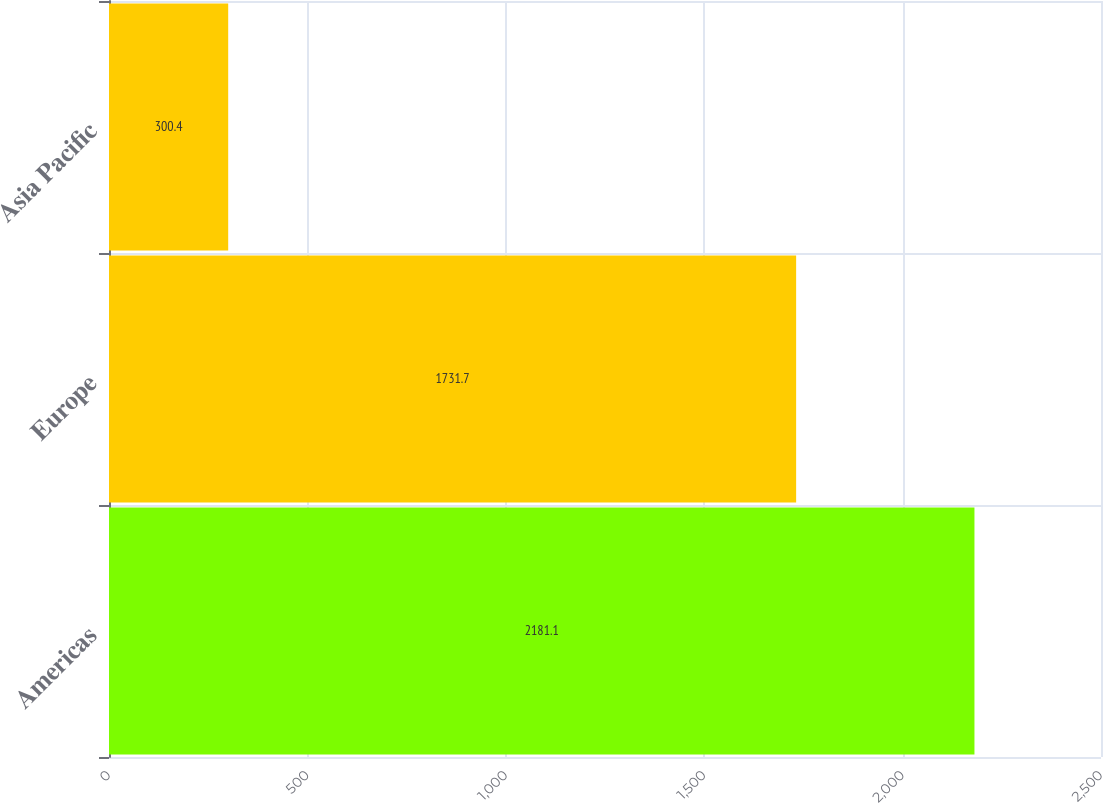Convert chart. <chart><loc_0><loc_0><loc_500><loc_500><bar_chart><fcel>Americas<fcel>Europe<fcel>Asia Pacific<nl><fcel>2181.1<fcel>1731.7<fcel>300.4<nl></chart> 